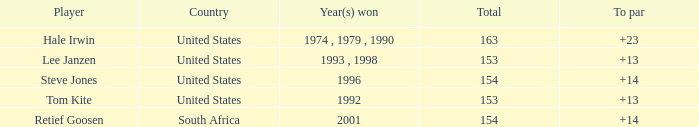What is the total that South Africa had a par greater than 14 None. 